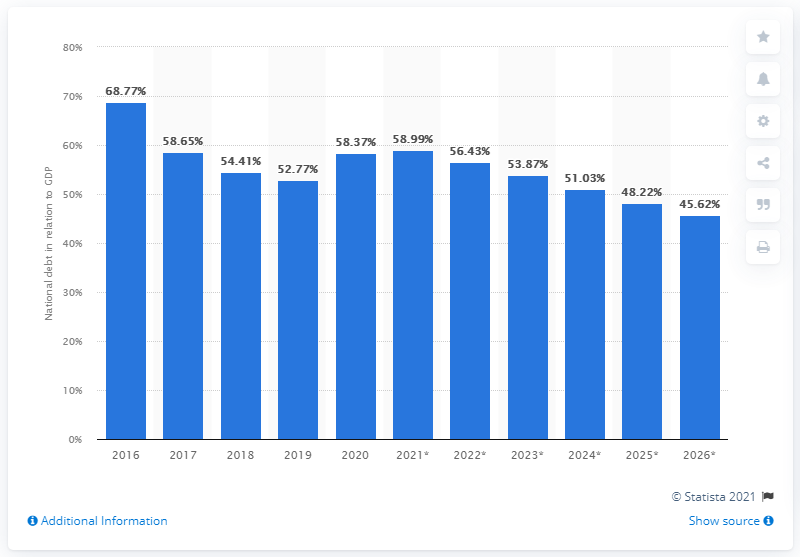List a handful of essential elements in this visual. In 2020, the national debt of Serbia represented 58.37% of the country's Gross Domestic Product (GDP). 